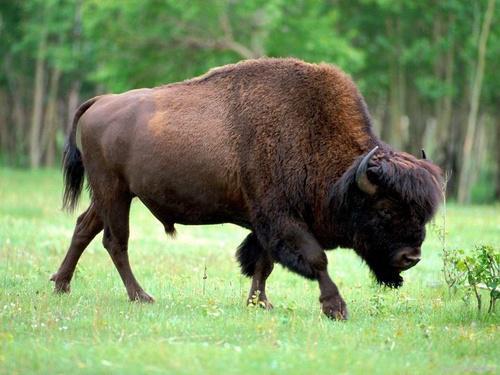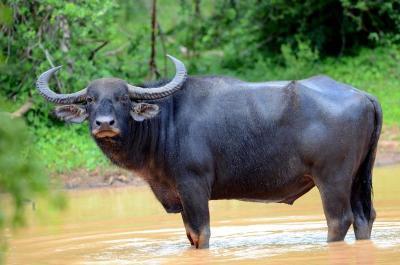The first image is the image on the left, the second image is the image on the right. Evaluate the accuracy of this statement regarding the images: "The animal in the image on the left is looking into the camera.". Is it true? Answer yes or no. No. 